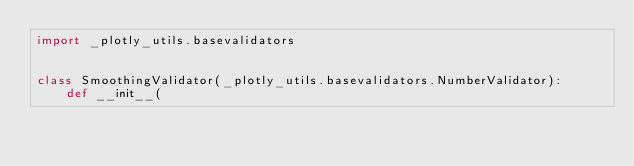Convert code to text. <code><loc_0><loc_0><loc_500><loc_500><_Python_>import _plotly_utils.basevalidators


class SmoothingValidator(_plotly_utils.basevalidators.NumberValidator):
    def __init__(</code> 